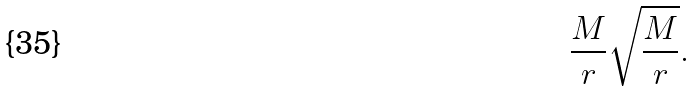Convert formula to latex. <formula><loc_0><loc_0><loc_500><loc_500>\frac { M } { r } \sqrt { \frac { M } { r } } .</formula> 